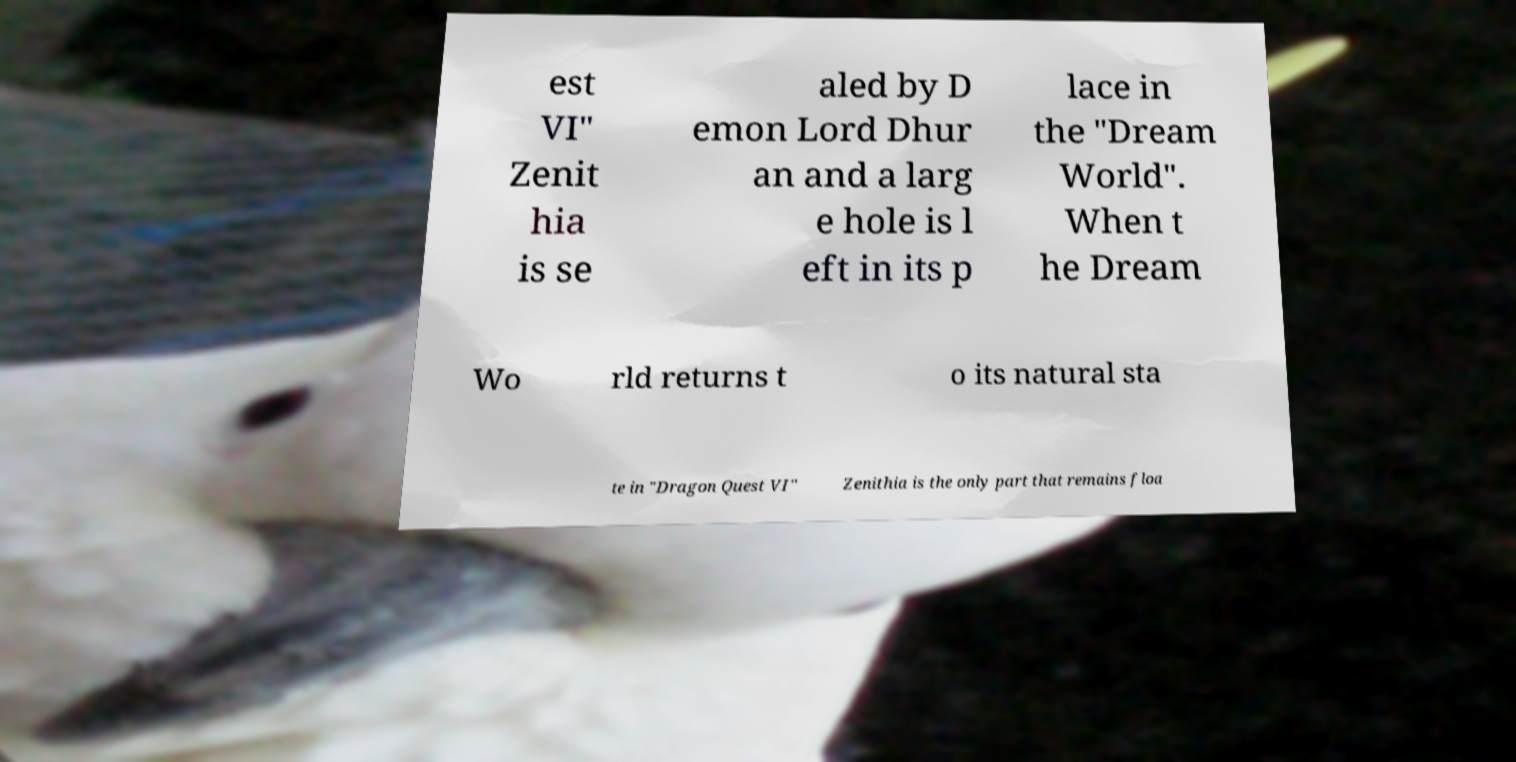Please read and relay the text visible in this image. What does it say? est VI" Zenit hia is se aled by D emon Lord Dhur an and a larg e hole is l eft in its p lace in the "Dream World". When t he Dream Wo rld returns t o its natural sta te in "Dragon Quest VI" Zenithia is the only part that remains floa 